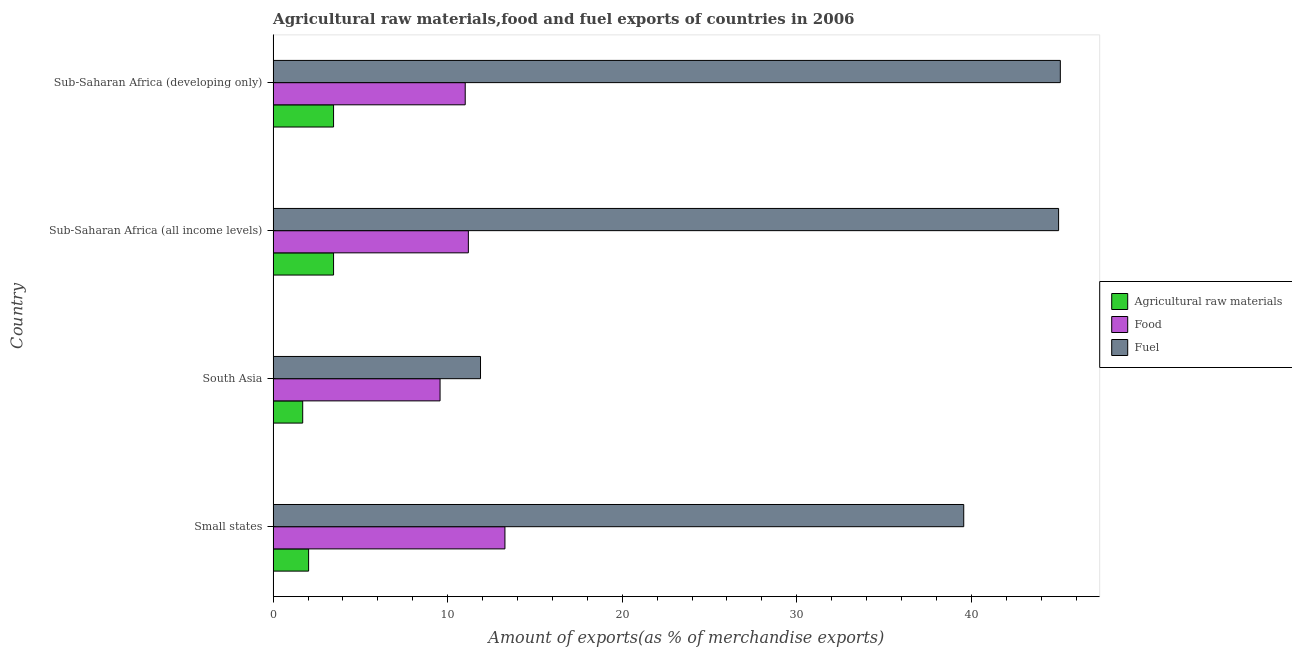How many groups of bars are there?
Your answer should be compact. 4. Are the number of bars on each tick of the Y-axis equal?
Provide a succinct answer. Yes. How many bars are there on the 4th tick from the top?
Provide a short and direct response. 3. What is the label of the 1st group of bars from the top?
Ensure brevity in your answer.  Sub-Saharan Africa (developing only). In how many cases, is the number of bars for a given country not equal to the number of legend labels?
Keep it short and to the point. 0. What is the percentage of fuel exports in Sub-Saharan Africa (developing only)?
Make the answer very short. 45.1. Across all countries, what is the maximum percentage of food exports?
Offer a very short reply. 13.28. Across all countries, what is the minimum percentage of raw materials exports?
Offer a very short reply. 1.69. In which country was the percentage of raw materials exports maximum?
Make the answer very short. Sub-Saharan Africa (all income levels). In which country was the percentage of raw materials exports minimum?
Ensure brevity in your answer.  South Asia. What is the total percentage of raw materials exports in the graph?
Your answer should be very brief. 10.65. What is the difference between the percentage of fuel exports in Small states and that in Sub-Saharan Africa (developing only)?
Make the answer very short. -5.53. What is the difference between the percentage of food exports in Sub-Saharan Africa (all income levels) and the percentage of raw materials exports in Small states?
Your response must be concise. 9.15. What is the average percentage of food exports per country?
Provide a succinct answer. 11.26. What is the difference between the percentage of fuel exports and percentage of food exports in South Asia?
Offer a terse response. 2.32. In how many countries, is the percentage of raw materials exports greater than 16 %?
Provide a succinct answer. 0. What is the ratio of the percentage of raw materials exports in South Asia to that in Sub-Saharan Africa (developing only)?
Make the answer very short. 0.49. Is the difference between the percentage of fuel exports in Sub-Saharan Africa (all income levels) and Sub-Saharan Africa (developing only) greater than the difference between the percentage of raw materials exports in Sub-Saharan Africa (all income levels) and Sub-Saharan Africa (developing only)?
Provide a short and direct response. No. What is the difference between the highest and the second highest percentage of fuel exports?
Ensure brevity in your answer.  0.1. What is the difference between the highest and the lowest percentage of fuel exports?
Offer a terse response. 33.22. Is the sum of the percentage of fuel exports in Sub-Saharan Africa (all income levels) and Sub-Saharan Africa (developing only) greater than the maximum percentage of raw materials exports across all countries?
Provide a succinct answer. Yes. What does the 1st bar from the top in South Asia represents?
Provide a short and direct response. Fuel. What does the 1st bar from the bottom in Sub-Saharan Africa (all income levels) represents?
Keep it short and to the point. Agricultural raw materials. Is it the case that in every country, the sum of the percentage of raw materials exports and percentage of food exports is greater than the percentage of fuel exports?
Ensure brevity in your answer.  No. How many bars are there?
Your answer should be compact. 12. What is the difference between two consecutive major ticks on the X-axis?
Give a very brief answer. 10. Are the values on the major ticks of X-axis written in scientific E-notation?
Ensure brevity in your answer.  No. Where does the legend appear in the graph?
Your response must be concise. Center right. What is the title of the graph?
Give a very brief answer. Agricultural raw materials,food and fuel exports of countries in 2006. Does "Male employers" appear as one of the legend labels in the graph?
Make the answer very short. No. What is the label or title of the X-axis?
Make the answer very short. Amount of exports(as % of merchandise exports). What is the Amount of exports(as % of merchandise exports) of Agricultural raw materials in Small states?
Your answer should be compact. 2.03. What is the Amount of exports(as % of merchandise exports) in Food in Small states?
Give a very brief answer. 13.28. What is the Amount of exports(as % of merchandise exports) in Fuel in Small states?
Your response must be concise. 39.56. What is the Amount of exports(as % of merchandise exports) of Agricultural raw materials in South Asia?
Your answer should be very brief. 1.69. What is the Amount of exports(as % of merchandise exports) of Food in South Asia?
Offer a very short reply. 9.56. What is the Amount of exports(as % of merchandise exports) in Fuel in South Asia?
Offer a very short reply. 11.88. What is the Amount of exports(as % of merchandise exports) of Agricultural raw materials in Sub-Saharan Africa (all income levels)?
Your answer should be compact. 3.46. What is the Amount of exports(as % of merchandise exports) in Food in Sub-Saharan Africa (all income levels)?
Offer a very short reply. 11.19. What is the Amount of exports(as % of merchandise exports) of Fuel in Sub-Saharan Africa (all income levels)?
Keep it short and to the point. 45. What is the Amount of exports(as % of merchandise exports) in Agricultural raw materials in Sub-Saharan Africa (developing only)?
Your response must be concise. 3.46. What is the Amount of exports(as % of merchandise exports) in Food in Sub-Saharan Africa (developing only)?
Offer a very short reply. 11. What is the Amount of exports(as % of merchandise exports) in Fuel in Sub-Saharan Africa (developing only)?
Ensure brevity in your answer.  45.1. Across all countries, what is the maximum Amount of exports(as % of merchandise exports) in Agricultural raw materials?
Your answer should be compact. 3.46. Across all countries, what is the maximum Amount of exports(as % of merchandise exports) in Food?
Ensure brevity in your answer.  13.28. Across all countries, what is the maximum Amount of exports(as % of merchandise exports) of Fuel?
Provide a succinct answer. 45.1. Across all countries, what is the minimum Amount of exports(as % of merchandise exports) of Agricultural raw materials?
Ensure brevity in your answer.  1.69. Across all countries, what is the minimum Amount of exports(as % of merchandise exports) in Food?
Your answer should be very brief. 9.56. Across all countries, what is the minimum Amount of exports(as % of merchandise exports) of Fuel?
Provide a succinct answer. 11.88. What is the total Amount of exports(as % of merchandise exports) of Agricultural raw materials in the graph?
Give a very brief answer. 10.65. What is the total Amount of exports(as % of merchandise exports) in Food in the graph?
Your answer should be very brief. 45.03. What is the total Amount of exports(as % of merchandise exports) of Fuel in the graph?
Give a very brief answer. 141.54. What is the difference between the Amount of exports(as % of merchandise exports) of Agricultural raw materials in Small states and that in South Asia?
Offer a very short reply. 0.34. What is the difference between the Amount of exports(as % of merchandise exports) of Food in Small states and that in South Asia?
Provide a short and direct response. 3.72. What is the difference between the Amount of exports(as % of merchandise exports) in Fuel in Small states and that in South Asia?
Provide a succinct answer. 27.68. What is the difference between the Amount of exports(as % of merchandise exports) of Agricultural raw materials in Small states and that in Sub-Saharan Africa (all income levels)?
Give a very brief answer. -1.43. What is the difference between the Amount of exports(as % of merchandise exports) in Food in Small states and that in Sub-Saharan Africa (all income levels)?
Your answer should be compact. 2.1. What is the difference between the Amount of exports(as % of merchandise exports) in Fuel in Small states and that in Sub-Saharan Africa (all income levels)?
Make the answer very short. -5.43. What is the difference between the Amount of exports(as % of merchandise exports) of Agricultural raw materials in Small states and that in Sub-Saharan Africa (developing only)?
Your answer should be compact. -1.43. What is the difference between the Amount of exports(as % of merchandise exports) of Food in Small states and that in Sub-Saharan Africa (developing only)?
Offer a very short reply. 2.28. What is the difference between the Amount of exports(as % of merchandise exports) in Fuel in Small states and that in Sub-Saharan Africa (developing only)?
Offer a terse response. -5.53. What is the difference between the Amount of exports(as % of merchandise exports) of Agricultural raw materials in South Asia and that in Sub-Saharan Africa (all income levels)?
Your answer should be compact. -1.77. What is the difference between the Amount of exports(as % of merchandise exports) in Food in South Asia and that in Sub-Saharan Africa (all income levels)?
Give a very brief answer. -1.62. What is the difference between the Amount of exports(as % of merchandise exports) in Fuel in South Asia and that in Sub-Saharan Africa (all income levels)?
Provide a succinct answer. -33.12. What is the difference between the Amount of exports(as % of merchandise exports) of Agricultural raw materials in South Asia and that in Sub-Saharan Africa (developing only)?
Give a very brief answer. -1.77. What is the difference between the Amount of exports(as % of merchandise exports) of Food in South Asia and that in Sub-Saharan Africa (developing only)?
Give a very brief answer. -1.44. What is the difference between the Amount of exports(as % of merchandise exports) of Fuel in South Asia and that in Sub-Saharan Africa (developing only)?
Provide a succinct answer. -33.22. What is the difference between the Amount of exports(as % of merchandise exports) in Agricultural raw materials in Sub-Saharan Africa (all income levels) and that in Sub-Saharan Africa (developing only)?
Give a very brief answer. 0. What is the difference between the Amount of exports(as % of merchandise exports) in Food in Sub-Saharan Africa (all income levels) and that in Sub-Saharan Africa (developing only)?
Provide a short and direct response. 0.18. What is the difference between the Amount of exports(as % of merchandise exports) of Fuel in Sub-Saharan Africa (all income levels) and that in Sub-Saharan Africa (developing only)?
Offer a terse response. -0.1. What is the difference between the Amount of exports(as % of merchandise exports) in Agricultural raw materials in Small states and the Amount of exports(as % of merchandise exports) in Food in South Asia?
Give a very brief answer. -7.53. What is the difference between the Amount of exports(as % of merchandise exports) in Agricultural raw materials in Small states and the Amount of exports(as % of merchandise exports) in Fuel in South Asia?
Provide a succinct answer. -9.85. What is the difference between the Amount of exports(as % of merchandise exports) of Food in Small states and the Amount of exports(as % of merchandise exports) of Fuel in South Asia?
Provide a short and direct response. 1.4. What is the difference between the Amount of exports(as % of merchandise exports) of Agricultural raw materials in Small states and the Amount of exports(as % of merchandise exports) of Food in Sub-Saharan Africa (all income levels)?
Provide a succinct answer. -9.15. What is the difference between the Amount of exports(as % of merchandise exports) in Agricultural raw materials in Small states and the Amount of exports(as % of merchandise exports) in Fuel in Sub-Saharan Africa (all income levels)?
Ensure brevity in your answer.  -42.97. What is the difference between the Amount of exports(as % of merchandise exports) of Food in Small states and the Amount of exports(as % of merchandise exports) of Fuel in Sub-Saharan Africa (all income levels)?
Make the answer very short. -31.72. What is the difference between the Amount of exports(as % of merchandise exports) in Agricultural raw materials in Small states and the Amount of exports(as % of merchandise exports) in Food in Sub-Saharan Africa (developing only)?
Your response must be concise. -8.97. What is the difference between the Amount of exports(as % of merchandise exports) in Agricultural raw materials in Small states and the Amount of exports(as % of merchandise exports) in Fuel in Sub-Saharan Africa (developing only)?
Your answer should be very brief. -43.07. What is the difference between the Amount of exports(as % of merchandise exports) in Food in Small states and the Amount of exports(as % of merchandise exports) in Fuel in Sub-Saharan Africa (developing only)?
Give a very brief answer. -31.82. What is the difference between the Amount of exports(as % of merchandise exports) in Agricultural raw materials in South Asia and the Amount of exports(as % of merchandise exports) in Food in Sub-Saharan Africa (all income levels)?
Make the answer very short. -9.49. What is the difference between the Amount of exports(as % of merchandise exports) in Agricultural raw materials in South Asia and the Amount of exports(as % of merchandise exports) in Fuel in Sub-Saharan Africa (all income levels)?
Your answer should be very brief. -43.3. What is the difference between the Amount of exports(as % of merchandise exports) of Food in South Asia and the Amount of exports(as % of merchandise exports) of Fuel in Sub-Saharan Africa (all income levels)?
Provide a short and direct response. -35.43. What is the difference between the Amount of exports(as % of merchandise exports) in Agricultural raw materials in South Asia and the Amount of exports(as % of merchandise exports) in Food in Sub-Saharan Africa (developing only)?
Provide a short and direct response. -9.31. What is the difference between the Amount of exports(as % of merchandise exports) of Agricultural raw materials in South Asia and the Amount of exports(as % of merchandise exports) of Fuel in Sub-Saharan Africa (developing only)?
Offer a terse response. -43.4. What is the difference between the Amount of exports(as % of merchandise exports) in Food in South Asia and the Amount of exports(as % of merchandise exports) in Fuel in Sub-Saharan Africa (developing only)?
Offer a terse response. -35.53. What is the difference between the Amount of exports(as % of merchandise exports) of Agricultural raw materials in Sub-Saharan Africa (all income levels) and the Amount of exports(as % of merchandise exports) of Food in Sub-Saharan Africa (developing only)?
Give a very brief answer. -7.54. What is the difference between the Amount of exports(as % of merchandise exports) of Agricultural raw materials in Sub-Saharan Africa (all income levels) and the Amount of exports(as % of merchandise exports) of Fuel in Sub-Saharan Africa (developing only)?
Your response must be concise. -41.64. What is the difference between the Amount of exports(as % of merchandise exports) in Food in Sub-Saharan Africa (all income levels) and the Amount of exports(as % of merchandise exports) in Fuel in Sub-Saharan Africa (developing only)?
Offer a terse response. -33.91. What is the average Amount of exports(as % of merchandise exports) in Agricultural raw materials per country?
Offer a very short reply. 2.66. What is the average Amount of exports(as % of merchandise exports) of Food per country?
Make the answer very short. 11.26. What is the average Amount of exports(as % of merchandise exports) of Fuel per country?
Give a very brief answer. 35.39. What is the difference between the Amount of exports(as % of merchandise exports) in Agricultural raw materials and Amount of exports(as % of merchandise exports) in Food in Small states?
Provide a succinct answer. -11.25. What is the difference between the Amount of exports(as % of merchandise exports) of Agricultural raw materials and Amount of exports(as % of merchandise exports) of Fuel in Small states?
Your response must be concise. -37.53. What is the difference between the Amount of exports(as % of merchandise exports) of Food and Amount of exports(as % of merchandise exports) of Fuel in Small states?
Provide a short and direct response. -26.28. What is the difference between the Amount of exports(as % of merchandise exports) of Agricultural raw materials and Amount of exports(as % of merchandise exports) of Food in South Asia?
Your response must be concise. -7.87. What is the difference between the Amount of exports(as % of merchandise exports) in Agricultural raw materials and Amount of exports(as % of merchandise exports) in Fuel in South Asia?
Keep it short and to the point. -10.19. What is the difference between the Amount of exports(as % of merchandise exports) of Food and Amount of exports(as % of merchandise exports) of Fuel in South Asia?
Offer a terse response. -2.32. What is the difference between the Amount of exports(as % of merchandise exports) of Agricultural raw materials and Amount of exports(as % of merchandise exports) of Food in Sub-Saharan Africa (all income levels)?
Ensure brevity in your answer.  -7.72. What is the difference between the Amount of exports(as % of merchandise exports) in Agricultural raw materials and Amount of exports(as % of merchandise exports) in Fuel in Sub-Saharan Africa (all income levels)?
Offer a very short reply. -41.54. What is the difference between the Amount of exports(as % of merchandise exports) of Food and Amount of exports(as % of merchandise exports) of Fuel in Sub-Saharan Africa (all income levels)?
Ensure brevity in your answer.  -33.81. What is the difference between the Amount of exports(as % of merchandise exports) of Agricultural raw materials and Amount of exports(as % of merchandise exports) of Food in Sub-Saharan Africa (developing only)?
Offer a terse response. -7.54. What is the difference between the Amount of exports(as % of merchandise exports) of Agricultural raw materials and Amount of exports(as % of merchandise exports) of Fuel in Sub-Saharan Africa (developing only)?
Your answer should be very brief. -41.64. What is the difference between the Amount of exports(as % of merchandise exports) of Food and Amount of exports(as % of merchandise exports) of Fuel in Sub-Saharan Africa (developing only)?
Give a very brief answer. -34.09. What is the ratio of the Amount of exports(as % of merchandise exports) in Agricultural raw materials in Small states to that in South Asia?
Provide a short and direct response. 1.2. What is the ratio of the Amount of exports(as % of merchandise exports) in Food in Small states to that in South Asia?
Keep it short and to the point. 1.39. What is the ratio of the Amount of exports(as % of merchandise exports) in Fuel in Small states to that in South Asia?
Provide a short and direct response. 3.33. What is the ratio of the Amount of exports(as % of merchandise exports) in Agricultural raw materials in Small states to that in Sub-Saharan Africa (all income levels)?
Your answer should be compact. 0.59. What is the ratio of the Amount of exports(as % of merchandise exports) of Food in Small states to that in Sub-Saharan Africa (all income levels)?
Ensure brevity in your answer.  1.19. What is the ratio of the Amount of exports(as % of merchandise exports) in Fuel in Small states to that in Sub-Saharan Africa (all income levels)?
Ensure brevity in your answer.  0.88. What is the ratio of the Amount of exports(as % of merchandise exports) of Agricultural raw materials in Small states to that in Sub-Saharan Africa (developing only)?
Offer a very short reply. 0.59. What is the ratio of the Amount of exports(as % of merchandise exports) of Food in Small states to that in Sub-Saharan Africa (developing only)?
Give a very brief answer. 1.21. What is the ratio of the Amount of exports(as % of merchandise exports) in Fuel in Small states to that in Sub-Saharan Africa (developing only)?
Your answer should be very brief. 0.88. What is the ratio of the Amount of exports(as % of merchandise exports) of Agricultural raw materials in South Asia to that in Sub-Saharan Africa (all income levels)?
Make the answer very short. 0.49. What is the ratio of the Amount of exports(as % of merchandise exports) of Food in South Asia to that in Sub-Saharan Africa (all income levels)?
Provide a short and direct response. 0.85. What is the ratio of the Amount of exports(as % of merchandise exports) in Fuel in South Asia to that in Sub-Saharan Africa (all income levels)?
Your response must be concise. 0.26. What is the ratio of the Amount of exports(as % of merchandise exports) of Agricultural raw materials in South Asia to that in Sub-Saharan Africa (developing only)?
Offer a very short reply. 0.49. What is the ratio of the Amount of exports(as % of merchandise exports) in Food in South Asia to that in Sub-Saharan Africa (developing only)?
Give a very brief answer. 0.87. What is the ratio of the Amount of exports(as % of merchandise exports) of Fuel in South Asia to that in Sub-Saharan Africa (developing only)?
Your answer should be compact. 0.26. What is the ratio of the Amount of exports(as % of merchandise exports) in Agricultural raw materials in Sub-Saharan Africa (all income levels) to that in Sub-Saharan Africa (developing only)?
Your answer should be compact. 1. What is the ratio of the Amount of exports(as % of merchandise exports) in Food in Sub-Saharan Africa (all income levels) to that in Sub-Saharan Africa (developing only)?
Give a very brief answer. 1.02. What is the ratio of the Amount of exports(as % of merchandise exports) of Fuel in Sub-Saharan Africa (all income levels) to that in Sub-Saharan Africa (developing only)?
Your response must be concise. 1. What is the difference between the highest and the second highest Amount of exports(as % of merchandise exports) in Food?
Provide a succinct answer. 2.1. What is the difference between the highest and the second highest Amount of exports(as % of merchandise exports) of Fuel?
Keep it short and to the point. 0.1. What is the difference between the highest and the lowest Amount of exports(as % of merchandise exports) in Agricultural raw materials?
Your answer should be compact. 1.77. What is the difference between the highest and the lowest Amount of exports(as % of merchandise exports) in Food?
Give a very brief answer. 3.72. What is the difference between the highest and the lowest Amount of exports(as % of merchandise exports) of Fuel?
Ensure brevity in your answer.  33.22. 